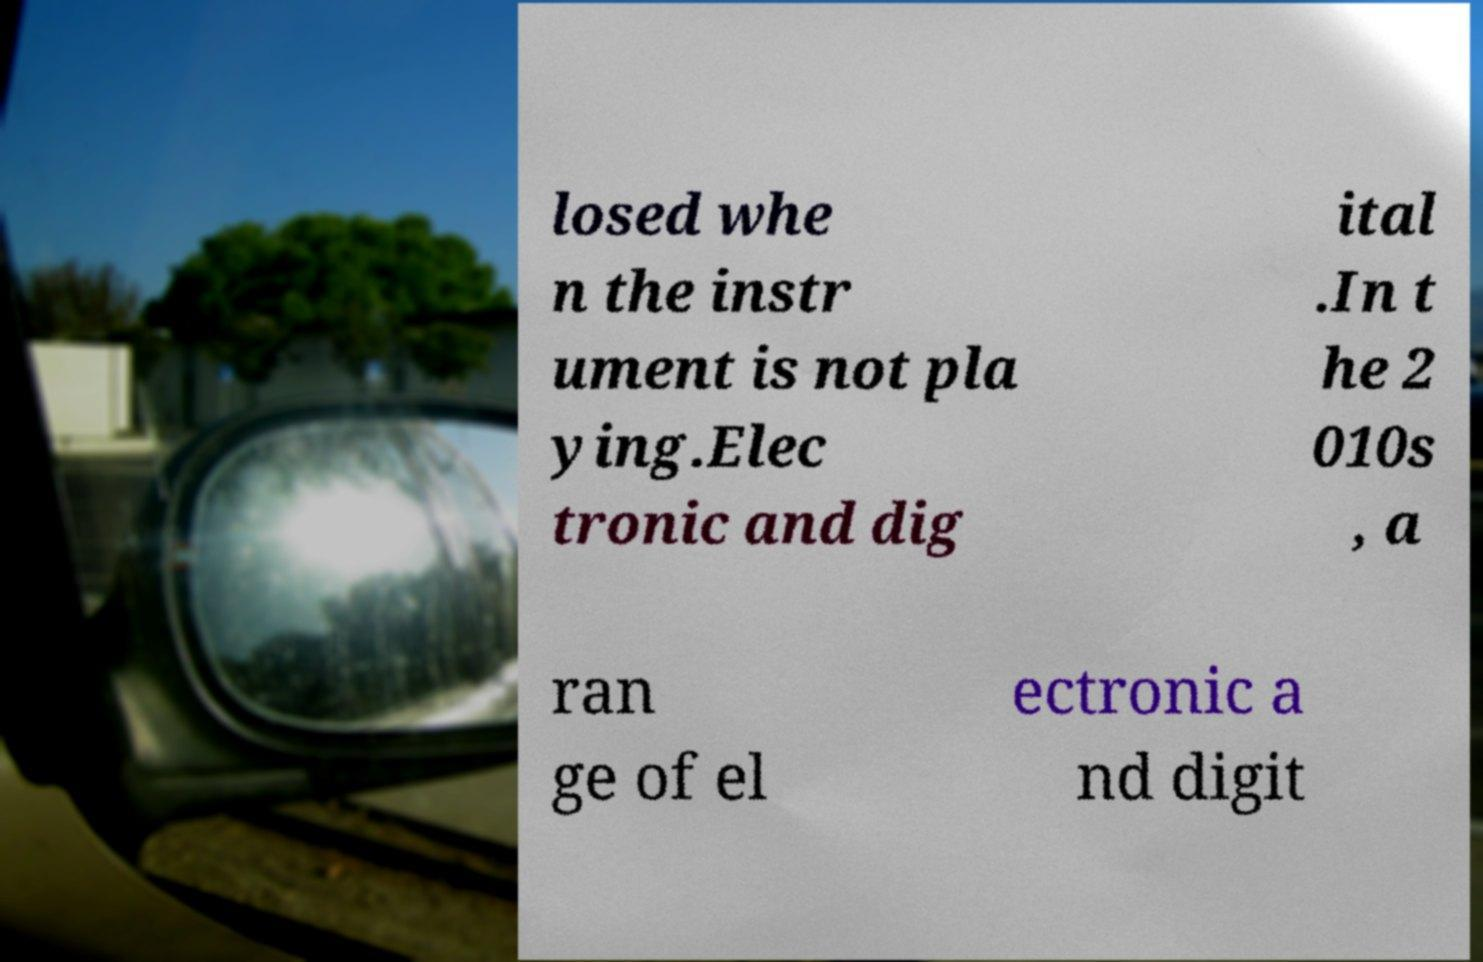There's text embedded in this image that I need extracted. Can you transcribe it verbatim? losed whe n the instr ument is not pla ying.Elec tronic and dig ital .In t he 2 010s , a ran ge of el ectronic a nd digit 